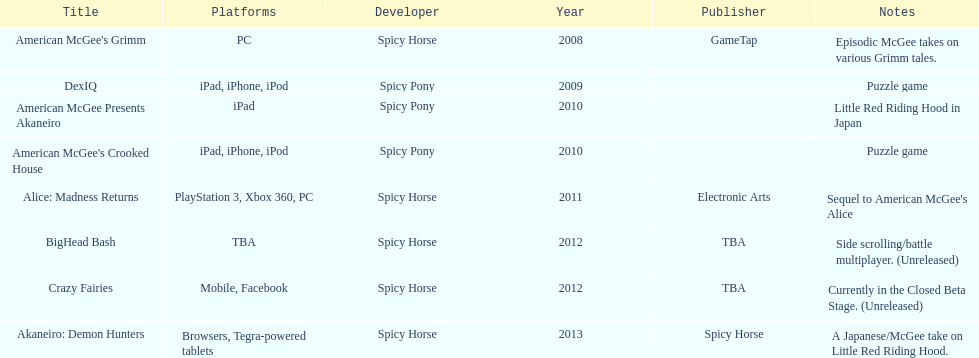What are the number of times an ipad was used as a platform? 3. 